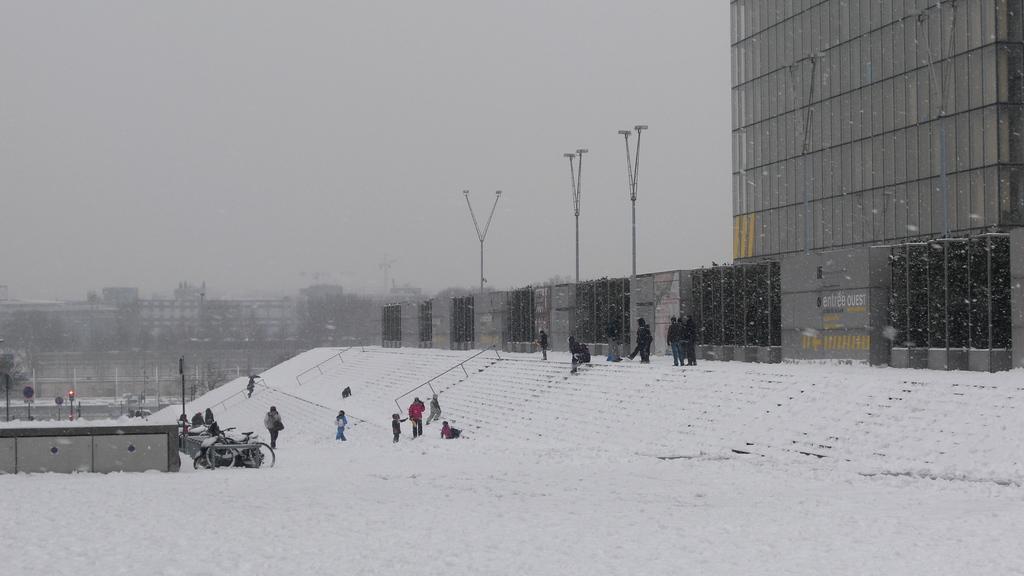How would you summarize this image in a sentence or two? In this image there are people standing. There is a railing. There are vehicles, traffic lights, light poles, boards and a few other objects. In the background of the image there are buildings, trees. At the bottom of the image there is snow on the surface. At the top of the image there is sky. 